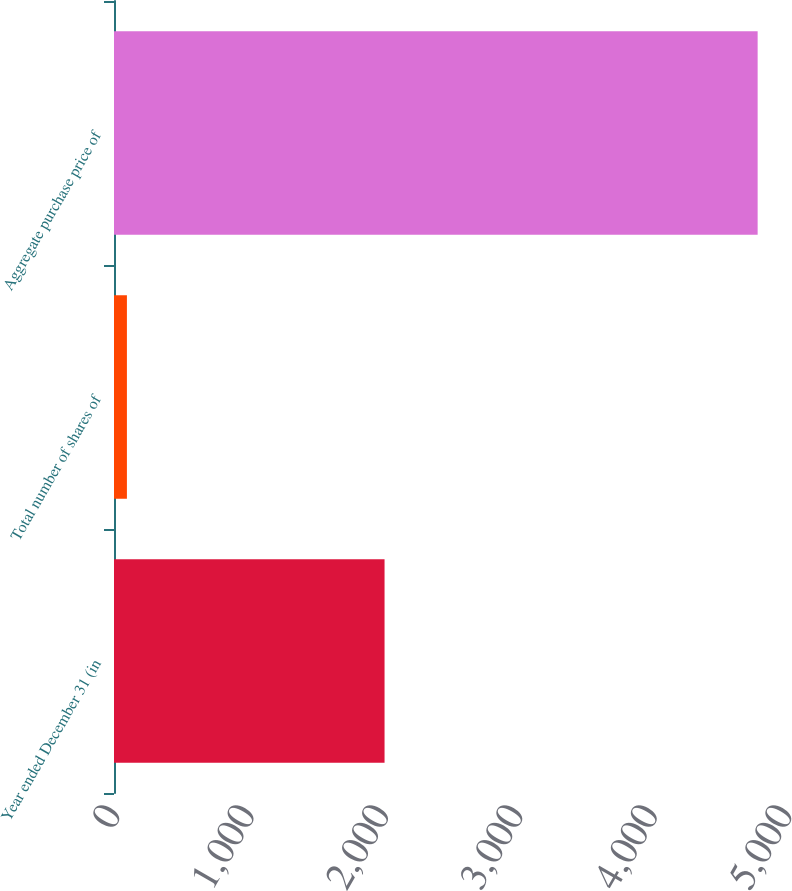<chart> <loc_0><loc_0><loc_500><loc_500><bar_chart><fcel>Year ended December 31 (in<fcel>Total number of shares of<fcel>Aggregate purchase price of<nl><fcel>2013<fcel>96.1<fcel>4789<nl></chart> 